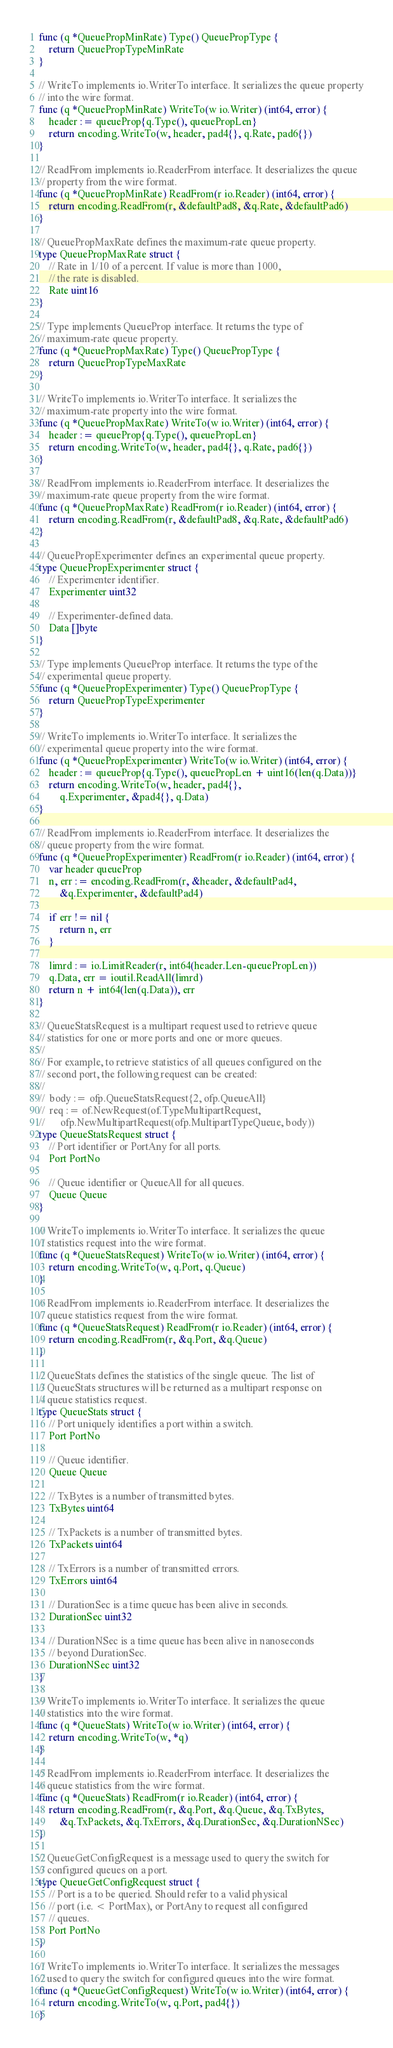Convert code to text. <code><loc_0><loc_0><loc_500><loc_500><_Go_>func (q *QueuePropMinRate) Type() QueuePropType {
	return QueuePropTypeMinRate
}

// WriteTo implements io.WriterTo interface. It serializes the queue property
// into the wire format.
func (q *QueuePropMinRate) WriteTo(w io.Writer) (int64, error) {
	header := queueProp{q.Type(), queuePropLen}
	return encoding.WriteTo(w, header, pad4{}, q.Rate, pad6{})
}

// ReadFrom implements io.ReaderFrom interface. It deserializes the queue
// property from the wire format.
func (q *QueuePropMinRate) ReadFrom(r io.Reader) (int64, error) {
	return encoding.ReadFrom(r, &defaultPad8, &q.Rate, &defaultPad6)
}

// QueuePropMaxRate defines the maximum-rate queue property.
type QueuePropMaxRate struct {
	// Rate in 1/10 of a percent. If value is more than 1000,
	// the rate is disabled.
	Rate uint16
}

// Type implements QueueProp interface. It returns the type of
// maximum-rate queue property.
func (q *QueuePropMaxRate) Type() QueuePropType {
	return QueuePropTypeMaxRate
}

// WriteTo implements io.WriterTo interface. It serializes the
// maximum-rate property into the wire format.
func (q *QueuePropMaxRate) WriteTo(w io.Writer) (int64, error) {
	header := queueProp{q.Type(), queuePropLen}
	return encoding.WriteTo(w, header, pad4{}, q.Rate, pad6{})
}

// ReadFrom implements io.ReaderFrom interface. It deserializes the
// maximum-rate queue property from the wire format.
func (q *QueuePropMaxRate) ReadFrom(r io.Reader) (int64, error) {
	return encoding.ReadFrom(r, &defaultPad8, &q.Rate, &defaultPad6)
}

// QueuePropExperimenter defines an experimental queue property.
type QueuePropExperimenter struct {
	// Experimenter identifier.
	Experimenter uint32

	// Experimenter-defined data.
	Data []byte
}

// Type implements QueueProp interface. It returns the type of the
// experimental queue property.
func (q *QueuePropExperimenter) Type() QueuePropType {
	return QueuePropTypeExperimenter
}

// WriteTo implements io.WriterTo interface. It serializes the
// experimental queue property into the wire format.
func (q *QueuePropExperimenter) WriteTo(w io.Writer) (int64, error) {
	header := queueProp{q.Type(), queuePropLen + uint16(len(q.Data))}
	return encoding.WriteTo(w, header, pad4{},
		q.Experimenter, &pad4{}, q.Data)
}

// ReadFrom implements io.ReaderFrom interface. It deserializes the
// queue property from the wire format.
func (q *QueuePropExperimenter) ReadFrom(r io.Reader) (int64, error) {
	var header queueProp
	n, err := encoding.ReadFrom(r, &header, &defaultPad4,
		&q.Experimenter, &defaultPad4)

	if err != nil {
		return n, err
	}

	limrd := io.LimitReader(r, int64(header.Len-queuePropLen))
	q.Data, err = ioutil.ReadAll(limrd)
	return n + int64(len(q.Data)), err
}

// QueueStatsRequest is a multipart request used to retrieve queue
// statistics for one or more ports and one or more queues.
//
// For example, to retrieve statistics of all queues configured on the
// second port, the following request can be created:
//
//	body := ofp.QueueStatsRequest{2, ofp.QueueAll}
//	req := of.NewRequest(of.TypeMultipartRequest,
//		ofp.NewMultipartRequest(ofp.MultipartTypeQueue, body))
type QueueStatsRequest struct {
	// Port identifier or PortAny for all ports.
	Port PortNo

	// Queue identifier or QueueAll for all queues.
	Queue Queue
}

// WriteTo implements io.WriterTo interface. It serializes the queue
// statistics request into the wire format.
func (q *QueueStatsRequest) WriteTo(w io.Writer) (int64, error) {
	return encoding.WriteTo(w, q.Port, q.Queue)
}

// ReadFrom implements io.ReaderFrom interface. It deserializes the
// queue statistics request from the wire format.
func (q *QueueStatsRequest) ReadFrom(r io.Reader) (int64, error) {
	return encoding.ReadFrom(r, &q.Port, &q.Queue)
}

// QueueStats defines the statistics of the single queue. The list of
// QueueStats structures will be returned as a multipart response on
// queue statistics request.
type QueueStats struct {
	// Port uniquely identifies a port within a switch.
	Port PortNo

	// Queue identifier.
	Queue Queue

	// TxBytes is a number of transmitted bytes.
	TxBytes uint64

	// TxPackets is a number of transmitted bytes.
	TxPackets uint64

	// TxErrors is a number of transmitted errors.
	TxErrors uint64

	// DurationSec is a time queue has been alive in seconds.
	DurationSec uint32

	// DurationNSec is a time queue has been alive in nanoseconds
	// beyond DurationSec.
	DurationNSec uint32
}

// WriteTo implements io.WriterTo interface. It serializes the queue
// statistics into the wire format.
func (q *QueueStats) WriteTo(w io.Writer) (int64, error) {
	return encoding.WriteTo(w, *q)
}

// ReadFrom implements io.ReaderFrom interface. It deserializes the
// queue statistics from the wire format.
func (q *QueueStats) ReadFrom(r io.Reader) (int64, error) {
	return encoding.ReadFrom(r, &q.Port, &q.Queue, &q.TxBytes,
		&q.TxPackets, &q.TxErrors, &q.DurationSec, &q.DurationNSec)
}

// QueueGetConfigRequest is a message used to query the switch for
// configured queues on a port.
type QueueGetConfigRequest struct {
	// Port is a to be queried. Should refer to a valid physical
	// port (i.e. < PortMax), or PortAny to request all configured
	// queues.
	Port PortNo
}

// WriteTo implements io.WriterTo interface. It serializes the messages
// used to query the switch for configured queues into the wire format.
func (q *QueueGetConfigRequest) WriteTo(w io.Writer) (int64, error) {
	return encoding.WriteTo(w, q.Port, pad4{})
}
</code> 